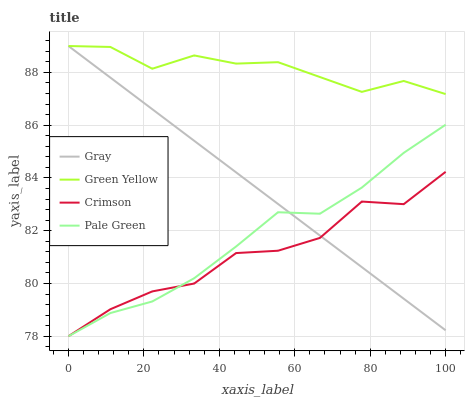Does Crimson have the minimum area under the curve?
Answer yes or no. Yes. Does Green Yellow have the maximum area under the curve?
Answer yes or no. Yes. Does Gray have the minimum area under the curve?
Answer yes or no. No. Does Gray have the maximum area under the curve?
Answer yes or no. No. Is Gray the smoothest?
Answer yes or no. Yes. Is Crimson the roughest?
Answer yes or no. Yes. Is Pale Green the smoothest?
Answer yes or no. No. Is Pale Green the roughest?
Answer yes or no. No. Does Gray have the lowest value?
Answer yes or no. No. Does Pale Green have the highest value?
Answer yes or no. No. Is Crimson less than Green Yellow?
Answer yes or no. Yes. Is Green Yellow greater than Pale Green?
Answer yes or no. Yes. Does Crimson intersect Green Yellow?
Answer yes or no. No. 